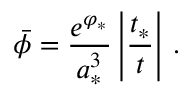<formula> <loc_0><loc_0><loc_500><loc_500>\bar { \phi } = { \frac { e ^ { \varphi _ { * } } } { a _ { * } ^ { 3 } } } \left | { \frac { t _ { * } } { t } } \right | \, .</formula> 